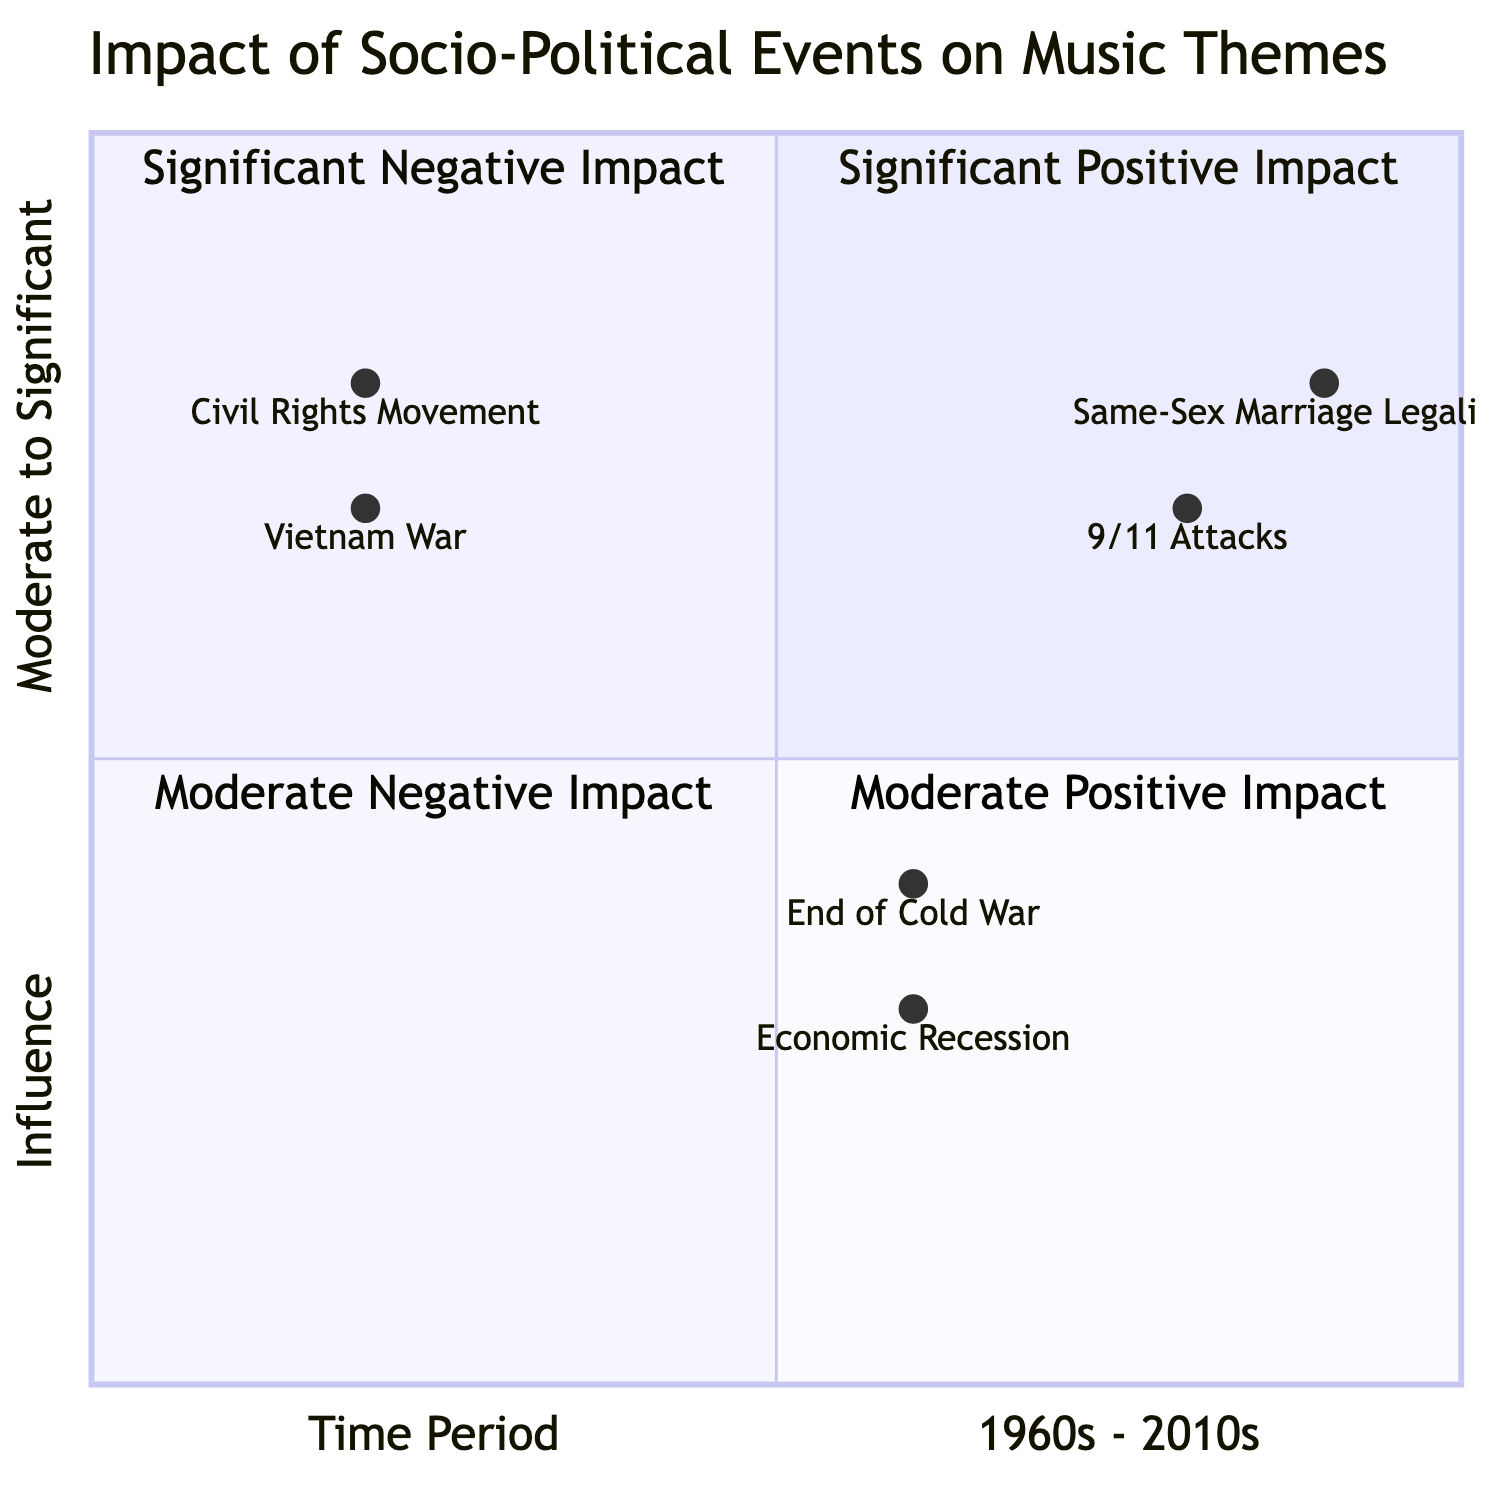What music theme corresponds with the Civil Rights Movement? The Civil Rights Movement is positioned in the Significant Positive Impact quadrant, and the diagram indicates that it relates to the music theme of "Freedom and Equality."
Answer: Freedom and Equality Which time period has the greatest negative influence? The time period with the greatest negative influence is the 2000s, specifically associated with the 9/11 Attacks, which has a high influence rating.
Answer: 2000s How many significant positive influences are shown on the chart? There are two significant positive influences shown on the chart: the Civil Rights Movement and Same-Sex Marriage Legalization. Counting both events yields a total of two.
Answer: 2 What event correlates with the theme of "Hope and Unity"? The event that correlates with the theme of "Hope and Unity" is the End of Cold War, as indicated in the Moderate Positive Impact quadrant.
Answer: End of Cold War Which quadrant contains the event related to the Economic Recession? The Economic Recession is placed in the Moderate Negative Impact quadrant, as represented in the diagram.
Answer: Moderate Negative Impact How does the influence of the Vietnam War compare to the End of Cold War? The Vietnam War has a significant influence rating while the End of Cold War has a moderate influence rating, indicating the Vietnam War is higher.
Answer: Significant vs Moderate 